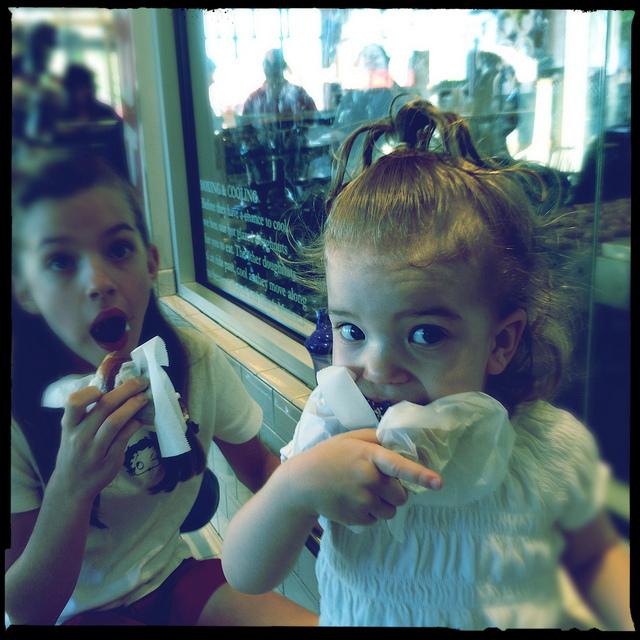What color is this kids shirt?
Concise answer only. White. What is the boy holding in his hand?
Concise answer only. Food. Which child is not blurred by the camera lens?
Be succinct. Right one. 